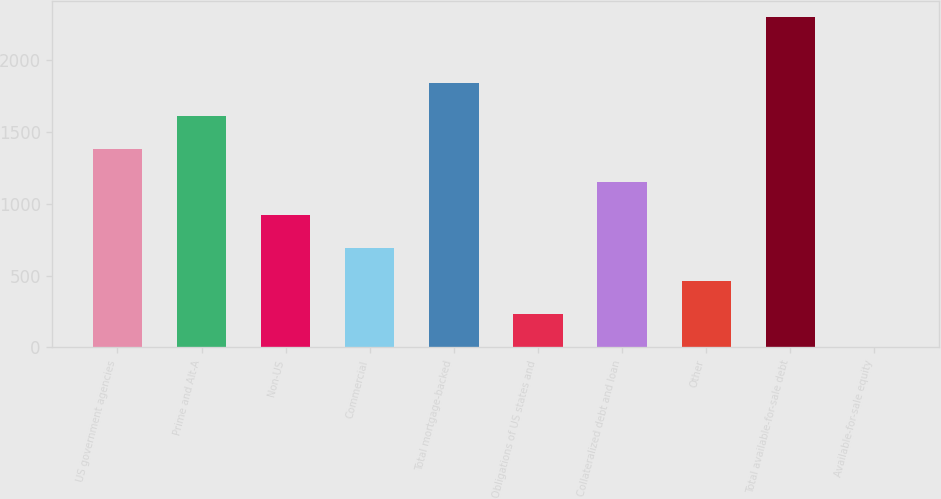Convert chart. <chart><loc_0><loc_0><loc_500><loc_500><bar_chart><fcel>US government agencies<fcel>Prime and Alt-A<fcel>Non-US<fcel>Commercial<fcel>Total mortgage-backed<fcel>Obligations of US states and<fcel>Collateralized debt and loan<fcel>Other<fcel>Total available-for-sale debt<fcel>Available-for-sale equity<nl><fcel>1384<fcel>1614<fcel>924<fcel>694<fcel>1844<fcel>234<fcel>1154<fcel>464<fcel>2300<fcel>4<nl></chart> 